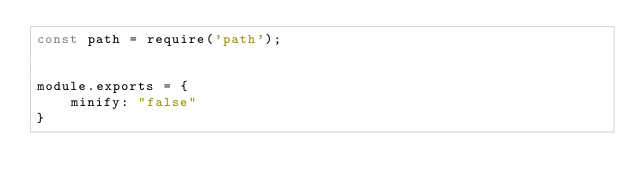<code> <loc_0><loc_0><loc_500><loc_500><_JavaScript_>const path = require('path');


module.exports = {
    minify: "false"
}</code> 